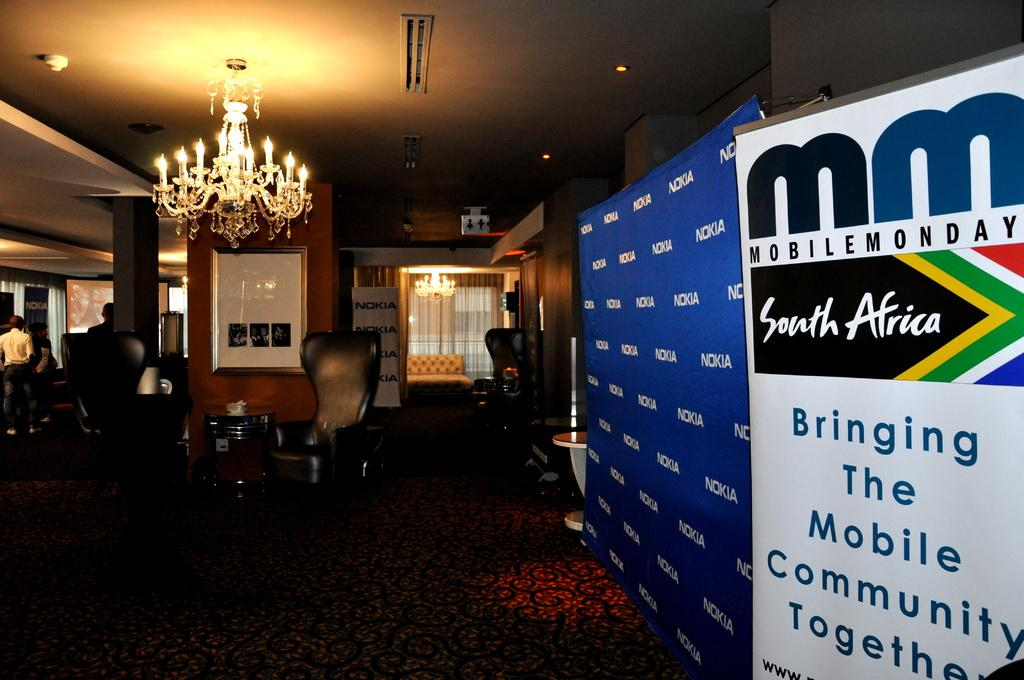Provide a one-sentence caption for the provided image. an ad banner for mobile monday looks like its part of an event. 